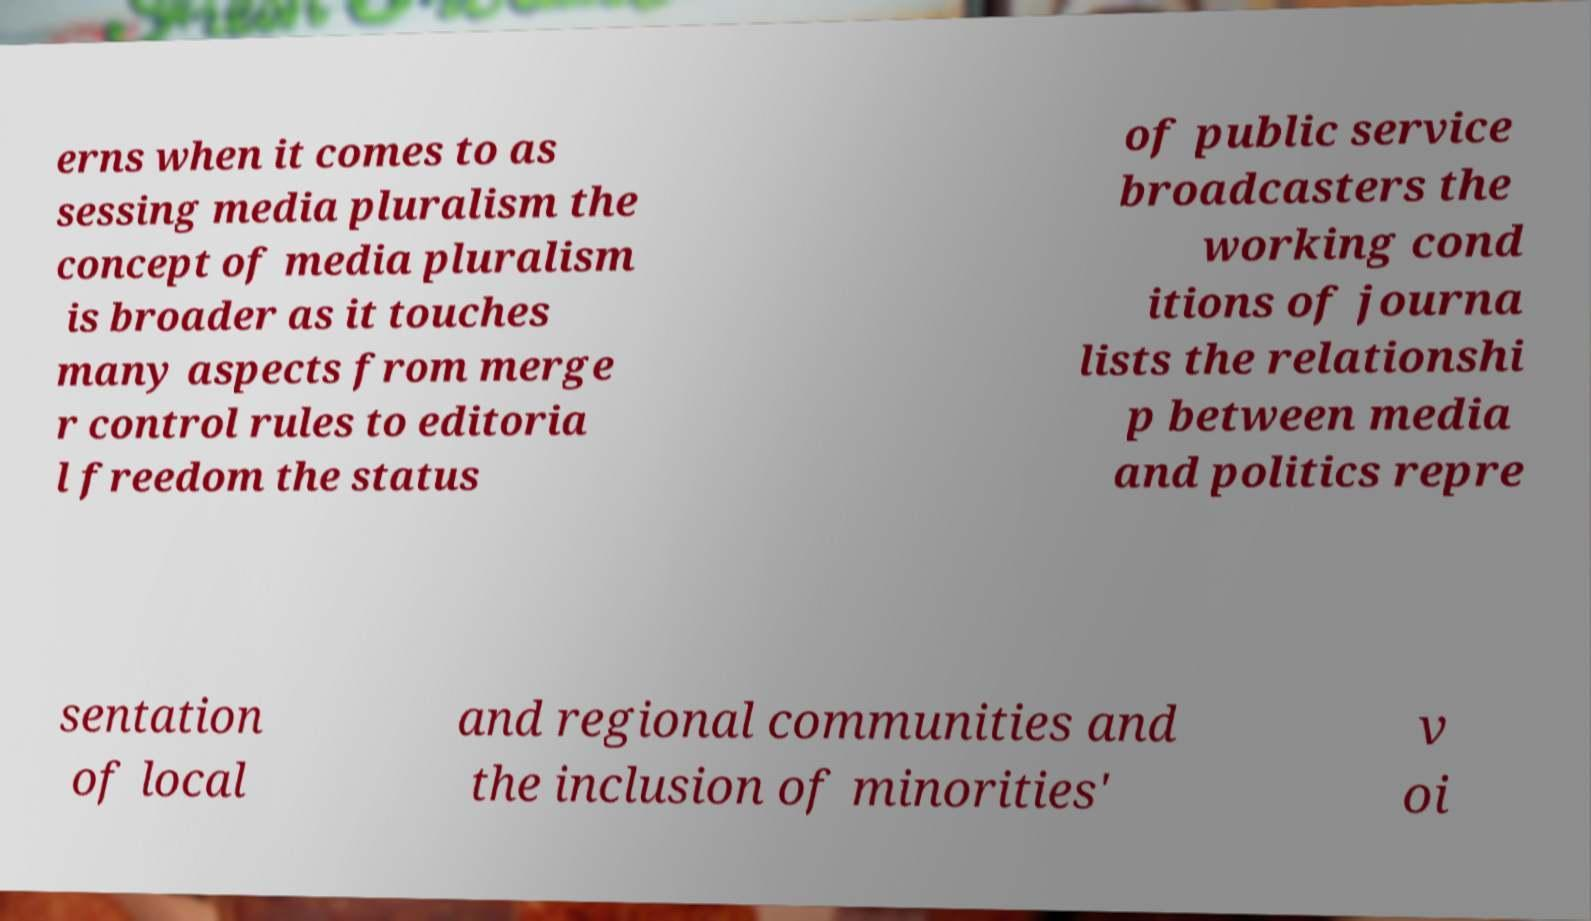Could you extract and type out the text from this image? erns when it comes to as sessing media pluralism the concept of media pluralism is broader as it touches many aspects from merge r control rules to editoria l freedom the status of public service broadcasters the working cond itions of journa lists the relationshi p between media and politics repre sentation of local and regional communities and the inclusion of minorities' v oi 